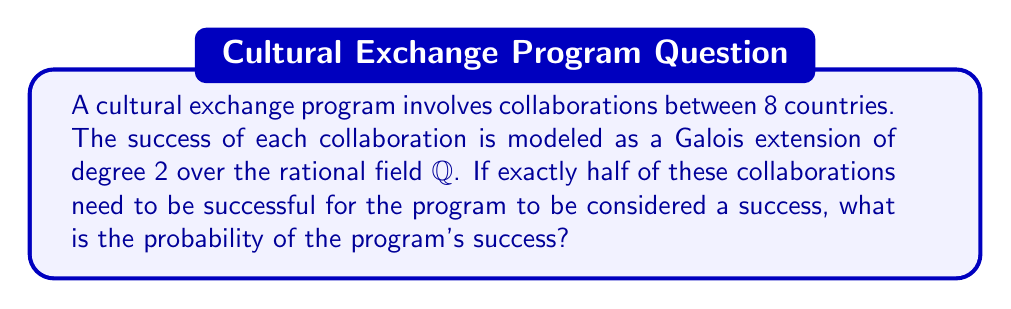Teach me how to tackle this problem. To solve this problem, we'll use concepts from Galois theory and probability theory:

1) Each collaboration is modeled as a Galois extension of degree 2 over $\mathbb{Q}$. This means each collaboration has two possible outcomes: success or failure.

2) The probability of success for each collaboration is 1/2, as there are two equally likely outcomes in a Galois extension of degree 2.

3) We need exactly 4 out of 8 collaborations to be successful for the program to succeed. This is a binomial probability problem.

4) The probability of exactly $k$ successes in $n$ trials with probability $p$ of success on each trial is given by the binomial probability formula:

   $$P(X = k) = \binom{n}{k} p^k (1-p)^{n-k}$$

5) In our case, $n = 8$, $k = 4$, and $p = 1/2$. Substituting these values:

   $$P(X = 4) = \binom{8}{4} (1/2)^4 (1/2)^{4}$$

6) Simplify:
   $$P(X = 4) = \frac{8!}{4!(8-4)!} \cdot \frac{1}{2^8}$$
   
   $$= \frac{8 \cdot 7 \cdot 6 \cdot 5}{4 \cdot 3 \cdot 2 \cdot 1} \cdot \frac{1}{256}$$
   
   $$= 70 \cdot \frac{1}{256} = \frac{70}{256} = \frac{35}{128}$$

Therefore, the probability of the program's success is $\frac{35}{128}$.
Answer: $\frac{35}{128}$ 